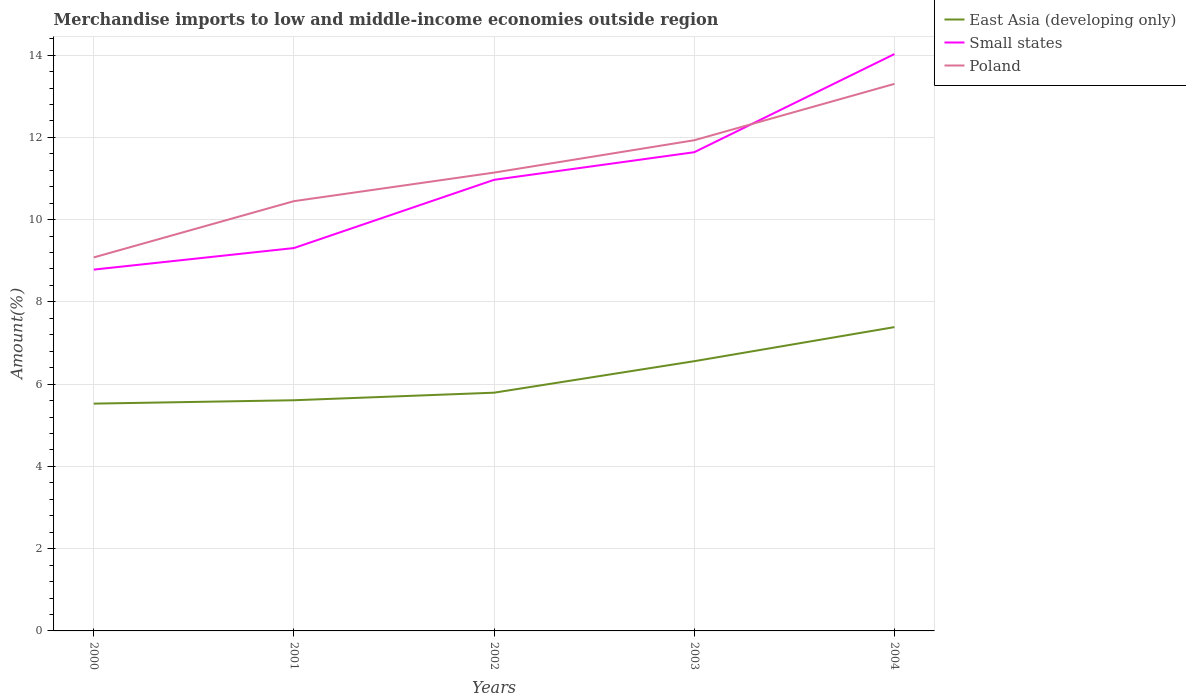Is the number of lines equal to the number of legend labels?
Offer a very short reply. Yes. Across all years, what is the maximum percentage of amount earned from merchandise imports in Poland?
Offer a terse response. 9.08. In which year was the percentage of amount earned from merchandise imports in East Asia (developing only) maximum?
Your answer should be very brief. 2000. What is the total percentage of amount earned from merchandise imports in Small states in the graph?
Provide a succinct answer. -2.33. What is the difference between the highest and the second highest percentage of amount earned from merchandise imports in East Asia (developing only)?
Make the answer very short. 1.86. How many lines are there?
Provide a short and direct response. 3. Are the values on the major ticks of Y-axis written in scientific E-notation?
Provide a succinct answer. No. Does the graph contain any zero values?
Keep it short and to the point. No. How are the legend labels stacked?
Provide a short and direct response. Vertical. What is the title of the graph?
Give a very brief answer. Merchandise imports to low and middle-income economies outside region. Does "Sint Maarten (Dutch part)" appear as one of the legend labels in the graph?
Offer a terse response. No. What is the label or title of the X-axis?
Keep it short and to the point. Years. What is the label or title of the Y-axis?
Provide a short and direct response. Amount(%). What is the Amount(%) of East Asia (developing only) in 2000?
Ensure brevity in your answer.  5.53. What is the Amount(%) in Small states in 2000?
Offer a terse response. 8.78. What is the Amount(%) of Poland in 2000?
Your answer should be very brief. 9.08. What is the Amount(%) of East Asia (developing only) in 2001?
Your answer should be compact. 5.61. What is the Amount(%) in Small states in 2001?
Your answer should be compact. 9.31. What is the Amount(%) in Poland in 2001?
Make the answer very short. 10.45. What is the Amount(%) of East Asia (developing only) in 2002?
Your response must be concise. 5.79. What is the Amount(%) in Small states in 2002?
Ensure brevity in your answer.  10.97. What is the Amount(%) in Poland in 2002?
Offer a terse response. 11.14. What is the Amount(%) in East Asia (developing only) in 2003?
Offer a very short reply. 6.56. What is the Amount(%) in Small states in 2003?
Provide a short and direct response. 11.64. What is the Amount(%) of Poland in 2003?
Keep it short and to the point. 11.93. What is the Amount(%) of East Asia (developing only) in 2004?
Offer a very short reply. 7.39. What is the Amount(%) of Small states in 2004?
Keep it short and to the point. 14.03. What is the Amount(%) in Poland in 2004?
Offer a terse response. 13.3. Across all years, what is the maximum Amount(%) of East Asia (developing only)?
Offer a terse response. 7.39. Across all years, what is the maximum Amount(%) of Small states?
Keep it short and to the point. 14.03. Across all years, what is the maximum Amount(%) in Poland?
Offer a terse response. 13.3. Across all years, what is the minimum Amount(%) of East Asia (developing only)?
Make the answer very short. 5.53. Across all years, what is the minimum Amount(%) of Small states?
Your answer should be compact. 8.78. Across all years, what is the minimum Amount(%) of Poland?
Keep it short and to the point. 9.08. What is the total Amount(%) of East Asia (developing only) in the graph?
Provide a succinct answer. 30.87. What is the total Amount(%) of Small states in the graph?
Offer a very short reply. 54.73. What is the total Amount(%) in Poland in the graph?
Make the answer very short. 55.9. What is the difference between the Amount(%) in East Asia (developing only) in 2000 and that in 2001?
Your response must be concise. -0.08. What is the difference between the Amount(%) of Small states in 2000 and that in 2001?
Your answer should be very brief. -0.52. What is the difference between the Amount(%) of Poland in 2000 and that in 2001?
Your answer should be very brief. -1.37. What is the difference between the Amount(%) in East Asia (developing only) in 2000 and that in 2002?
Offer a terse response. -0.27. What is the difference between the Amount(%) in Small states in 2000 and that in 2002?
Make the answer very short. -2.18. What is the difference between the Amount(%) in Poland in 2000 and that in 2002?
Offer a terse response. -2.06. What is the difference between the Amount(%) in East Asia (developing only) in 2000 and that in 2003?
Make the answer very short. -1.03. What is the difference between the Amount(%) of Small states in 2000 and that in 2003?
Your answer should be very brief. -2.85. What is the difference between the Amount(%) in Poland in 2000 and that in 2003?
Offer a terse response. -2.85. What is the difference between the Amount(%) in East Asia (developing only) in 2000 and that in 2004?
Offer a very short reply. -1.86. What is the difference between the Amount(%) in Small states in 2000 and that in 2004?
Keep it short and to the point. -5.24. What is the difference between the Amount(%) in Poland in 2000 and that in 2004?
Give a very brief answer. -4.22. What is the difference between the Amount(%) of East Asia (developing only) in 2001 and that in 2002?
Your response must be concise. -0.18. What is the difference between the Amount(%) in Small states in 2001 and that in 2002?
Your answer should be compact. -1.66. What is the difference between the Amount(%) in Poland in 2001 and that in 2002?
Your answer should be compact. -0.69. What is the difference between the Amount(%) of East Asia (developing only) in 2001 and that in 2003?
Provide a succinct answer. -0.95. What is the difference between the Amount(%) in Small states in 2001 and that in 2003?
Give a very brief answer. -2.33. What is the difference between the Amount(%) of Poland in 2001 and that in 2003?
Make the answer very short. -1.48. What is the difference between the Amount(%) of East Asia (developing only) in 2001 and that in 2004?
Give a very brief answer. -1.78. What is the difference between the Amount(%) in Small states in 2001 and that in 2004?
Give a very brief answer. -4.72. What is the difference between the Amount(%) of Poland in 2001 and that in 2004?
Provide a short and direct response. -2.85. What is the difference between the Amount(%) in East Asia (developing only) in 2002 and that in 2003?
Provide a short and direct response. -0.77. What is the difference between the Amount(%) of Small states in 2002 and that in 2003?
Your answer should be compact. -0.67. What is the difference between the Amount(%) in Poland in 2002 and that in 2003?
Keep it short and to the point. -0.79. What is the difference between the Amount(%) in East Asia (developing only) in 2002 and that in 2004?
Provide a short and direct response. -1.59. What is the difference between the Amount(%) in Small states in 2002 and that in 2004?
Give a very brief answer. -3.06. What is the difference between the Amount(%) in Poland in 2002 and that in 2004?
Provide a succinct answer. -2.16. What is the difference between the Amount(%) of East Asia (developing only) in 2003 and that in 2004?
Offer a terse response. -0.83. What is the difference between the Amount(%) of Small states in 2003 and that in 2004?
Give a very brief answer. -2.39. What is the difference between the Amount(%) in Poland in 2003 and that in 2004?
Your answer should be compact. -1.37. What is the difference between the Amount(%) of East Asia (developing only) in 2000 and the Amount(%) of Small states in 2001?
Your answer should be very brief. -3.78. What is the difference between the Amount(%) in East Asia (developing only) in 2000 and the Amount(%) in Poland in 2001?
Provide a succinct answer. -4.92. What is the difference between the Amount(%) in Small states in 2000 and the Amount(%) in Poland in 2001?
Your answer should be very brief. -1.66. What is the difference between the Amount(%) in East Asia (developing only) in 2000 and the Amount(%) in Small states in 2002?
Offer a very short reply. -5.44. What is the difference between the Amount(%) in East Asia (developing only) in 2000 and the Amount(%) in Poland in 2002?
Provide a succinct answer. -5.62. What is the difference between the Amount(%) in Small states in 2000 and the Amount(%) in Poland in 2002?
Provide a succinct answer. -2.36. What is the difference between the Amount(%) in East Asia (developing only) in 2000 and the Amount(%) in Small states in 2003?
Give a very brief answer. -6.11. What is the difference between the Amount(%) of East Asia (developing only) in 2000 and the Amount(%) of Poland in 2003?
Ensure brevity in your answer.  -6.4. What is the difference between the Amount(%) in Small states in 2000 and the Amount(%) in Poland in 2003?
Your response must be concise. -3.15. What is the difference between the Amount(%) in East Asia (developing only) in 2000 and the Amount(%) in Small states in 2004?
Offer a very short reply. -8.5. What is the difference between the Amount(%) in East Asia (developing only) in 2000 and the Amount(%) in Poland in 2004?
Offer a very short reply. -7.77. What is the difference between the Amount(%) of Small states in 2000 and the Amount(%) of Poland in 2004?
Your response must be concise. -4.52. What is the difference between the Amount(%) of East Asia (developing only) in 2001 and the Amount(%) of Small states in 2002?
Make the answer very short. -5.36. What is the difference between the Amount(%) of East Asia (developing only) in 2001 and the Amount(%) of Poland in 2002?
Your answer should be compact. -5.54. What is the difference between the Amount(%) of Small states in 2001 and the Amount(%) of Poland in 2002?
Ensure brevity in your answer.  -1.83. What is the difference between the Amount(%) in East Asia (developing only) in 2001 and the Amount(%) in Small states in 2003?
Your response must be concise. -6.03. What is the difference between the Amount(%) in East Asia (developing only) in 2001 and the Amount(%) in Poland in 2003?
Provide a succinct answer. -6.32. What is the difference between the Amount(%) in Small states in 2001 and the Amount(%) in Poland in 2003?
Make the answer very short. -2.62. What is the difference between the Amount(%) in East Asia (developing only) in 2001 and the Amount(%) in Small states in 2004?
Your response must be concise. -8.42. What is the difference between the Amount(%) of East Asia (developing only) in 2001 and the Amount(%) of Poland in 2004?
Keep it short and to the point. -7.69. What is the difference between the Amount(%) in Small states in 2001 and the Amount(%) in Poland in 2004?
Provide a short and direct response. -3.99. What is the difference between the Amount(%) in East Asia (developing only) in 2002 and the Amount(%) in Small states in 2003?
Provide a short and direct response. -5.85. What is the difference between the Amount(%) in East Asia (developing only) in 2002 and the Amount(%) in Poland in 2003?
Provide a succinct answer. -6.14. What is the difference between the Amount(%) in Small states in 2002 and the Amount(%) in Poland in 2003?
Your answer should be very brief. -0.96. What is the difference between the Amount(%) of East Asia (developing only) in 2002 and the Amount(%) of Small states in 2004?
Your answer should be very brief. -8.23. What is the difference between the Amount(%) in East Asia (developing only) in 2002 and the Amount(%) in Poland in 2004?
Make the answer very short. -7.51. What is the difference between the Amount(%) in Small states in 2002 and the Amount(%) in Poland in 2004?
Your response must be concise. -2.33. What is the difference between the Amount(%) in East Asia (developing only) in 2003 and the Amount(%) in Small states in 2004?
Your response must be concise. -7.47. What is the difference between the Amount(%) in East Asia (developing only) in 2003 and the Amount(%) in Poland in 2004?
Your answer should be very brief. -6.74. What is the difference between the Amount(%) in Small states in 2003 and the Amount(%) in Poland in 2004?
Your answer should be compact. -1.66. What is the average Amount(%) in East Asia (developing only) per year?
Provide a succinct answer. 6.17. What is the average Amount(%) of Small states per year?
Offer a very short reply. 10.95. What is the average Amount(%) in Poland per year?
Your answer should be compact. 11.18. In the year 2000, what is the difference between the Amount(%) in East Asia (developing only) and Amount(%) in Small states?
Your response must be concise. -3.26. In the year 2000, what is the difference between the Amount(%) of East Asia (developing only) and Amount(%) of Poland?
Your answer should be compact. -3.55. In the year 2000, what is the difference between the Amount(%) of Small states and Amount(%) of Poland?
Make the answer very short. -0.3. In the year 2001, what is the difference between the Amount(%) in East Asia (developing only) and Amount(%) in Small states?
Offer a very short reply. -3.7. In the year 2001, what is the difference between the Amount(%) in East Asia (developing only) and Amount(%) in Poland?
Offer a terse response. -4.84. In the year 2001, what is the difference between the Amount(%) in Small states and Amount(%) in Poland?
Offer a very short reply. -1.14. In the year 2002, what is the difference between the Amount(%) of East Asia (developing only) and Amount(%) of Small states?
Your response must be concise. -5.18. In the year 2002, what is the difference between the Amount(%) in East Asia (developing only) and Amount(%) in Poland?
Your answer should be very brief. -5.35. In the year 2002, what is the difference between the Amount(%) in Small states and Amount(%) in Poland?
Offer a very short reply. -0.18. In the year 2003, what is the difference between the Amount(%) in East Asia (developing only) and Amount(%) in Small states?
Provide a succinct answer. -5.08. In the year 2003, what is the difference between the Amount(%) of East Asia (developing only) and Amount(%) of Poland?
Ensure brevity in your answer.  -5.37. In the year 2003, what is the difference between the Amount(%) in Small states and Amount(%) in Poland?
Ensure brevity in your answer.  -0.29. In the year 2004, what is the difference between the Amount(%) of East Asia (developing only) and Amount(%) of Small states?
Ensure brevity in your answer.  -6.64. In the year 2004, what is the difference between the Amount(%) of East Asia (developing only) and Amount(%) of Poland?
Your answer should be compact. -5.91. In the year 2004, what is the difference between the Amount(%) of Small states and Amount(%) of Poland?
Offer a very short reply. 0.72. What is the ratio of the Amount(%) in East Asia (developing only) in 2000 to that in 2001?
Ensure brevity in your answer.  0.99. What is the ratio of the Amount(%) in Small states in 2000 to that in 2001?
Make the answer very short. 0.94. What is the ratio of the Amount(%) in Poland in 2000 to that in 2001?
Ensure brevity in your answer.  0.87. What is the ratio of the Amount(%) of East Asia (developing only) in 2000 to that in 2002?
Make the answer very short. 0.95. What is the ratio of the Amount(%) of Small states in 2000 to that in 2002?
Make the answer very short. 0.8. What is the ratio of the Amount(%) of Poland in 2000 to that in 2002?
Your answer should be very brief. 0.81. What is the ratio of the Amount(%) in East Asia (developing only) in 2000 to that in 2003?
Your response must be concise. 0.84. What is the ratio of the Amount(%) of Small states in 2000 to that in 2003?
Your answer should be compact. 0.75. What is the ratio of the Amount(%) of Poland in 2000 to that in 2003?
Ensure brevity in your answer.  0.76. What is the ratio of the Amount(%) in East Asia (developing only) in 2000 to that in 2004?
Provide a short and direct response. 0.75. What is the ratio of the Amount(%) of Small states in 2000 to that in 2004?
Give a very brief answer. 0.63. What is the ratio of the Amount(%) of Poland in 2000 to that in 2004?
Your answer should be compact. 0.68. What is the ratio of the Amount(%) of East Asia (developing only) in 2001 to that in 2002?
Provide a short and direct response. 0.97. What is the ratio of the Amount(%) of Small states in 2001 to that in 2002?
Provide a short and direct response. 0.85. What is the ratio of the Amount(%) of Poland in 2001 to that in 2002?
Ensure brevity in your answer.  0.94. What is the ratio of the Amount(%) in East Asia (developing only) in 2001 to that in 2003?
Your response must be concise. 0.86. What is the ratio of the Amount(%) in Small states in 2001 to that in 2003?
Provide a short and direct response. 0.8. What is the ratio of the Amount(%) in Poland in 2001 to that in 2003?
Ensure brevity in your answer.  0.88. What is the ratio of the Amount(%) in East Asia (developing only) in 2001 to that in 2004?
Your answer should be compact. 0.76. What is the ratio of the Amount(%) in Small states in 2001 to that in 2004?
Give a very brief answer. 0.66. What is the ratio of the Amount(%) of Poland in 2001 to that in 2004?
Keep it short and to the point. 0.79. What is the ratio of the Amount(%) in East Asia (developing only) in 2002 to that in 2003?
Ensure brevity in your answer.  0.88. What is the ratio of the Amount(%) of Small states in 2002 to that in 2003?
Ensure brevity in your answer.  0.94. What is the ratio of the Amount(%) of Poland in 2002 to that in 2003?
Your answer should be very brief. 0.93. What is the ratio of the Amount(%) of East Asia (developing only) in 2002 to that in 2004?
Ensure brevity in your answer.  0.78. What is the ratio of the Amount(%) of Small states in 2002 to that in 2004?
Give a very brief answer. 0.78. What is the ratio of the Amount(%) of Poland in 2002 to that in 2004?
Your answer should be compact. 0.84. What is the ratio of the Amount(%) of East Asia (developing only) in 2003 to that in 2004?
Give a very brief answer. 0.89. What is the ratio of the Amount(%) of Small states in 2003 to that in 2004?
Your answer should be very brief. 0.83. What is the ratio of the Amount(%) in Poland in 2003 to that in 2004?
Your response must be concise. 0.9. What is the difference between the highest and the second highest Amount(%) in East Asia (developing only)?
Keep it short and to the point. 0.83. What is the difference between the highest and the second highest Amount(%) in Small states?
Your answer should be compact. 2.39. What is the difference between the highest and the second highest Amount(%) of Poland?
Your answer should be very brief. 1.37. What is the difference between the highest and the lowest Amount(%) in East Asia (developing only)?
Provide a short and direct response. 1.86. What is the difference between the highest and the lowest Amount(%) in Small states?
Give a very brief answer. 5.24. What is the difference between the highest and the lowest Amount(%) in Poland?
Ensure brevity in your answer.  4.22. 